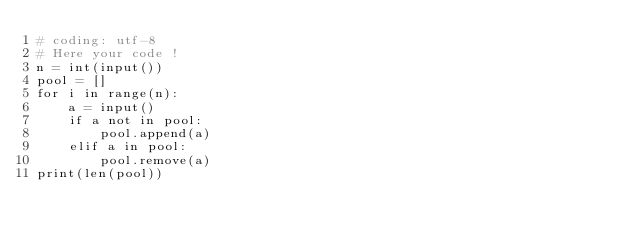<code> <loc_0><loc_0><loc_500><loc_500><_Python_># coding: utf-8
# Here your code !
n = int(input())
pool = []
for i in range(n):
    a = input()
    if a not in pool:
        pool.append(a)
    elif a in pool:
        pool.remove(a)
print(len(pool))
</code> 